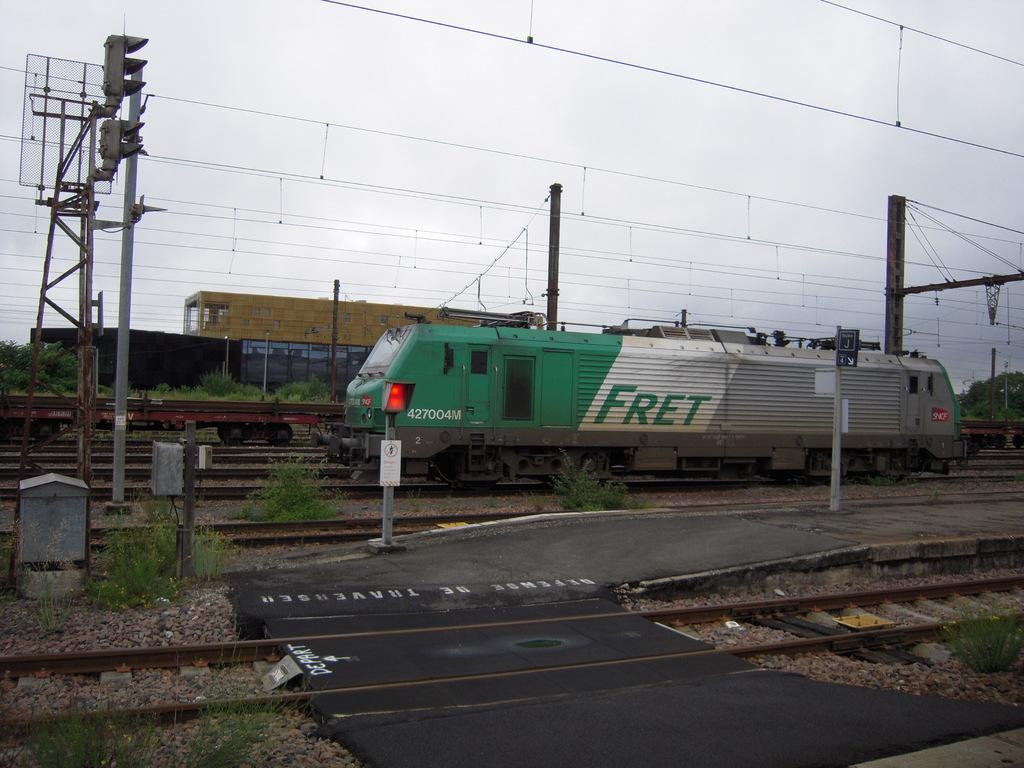What is the big word wrote on the train?
Your response must be concise. Fret. 